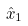Convert formula to latex. <formula><loc_0><loc_0><loc_500><loc_500>\hat { x } _ { 1 }</formula> 